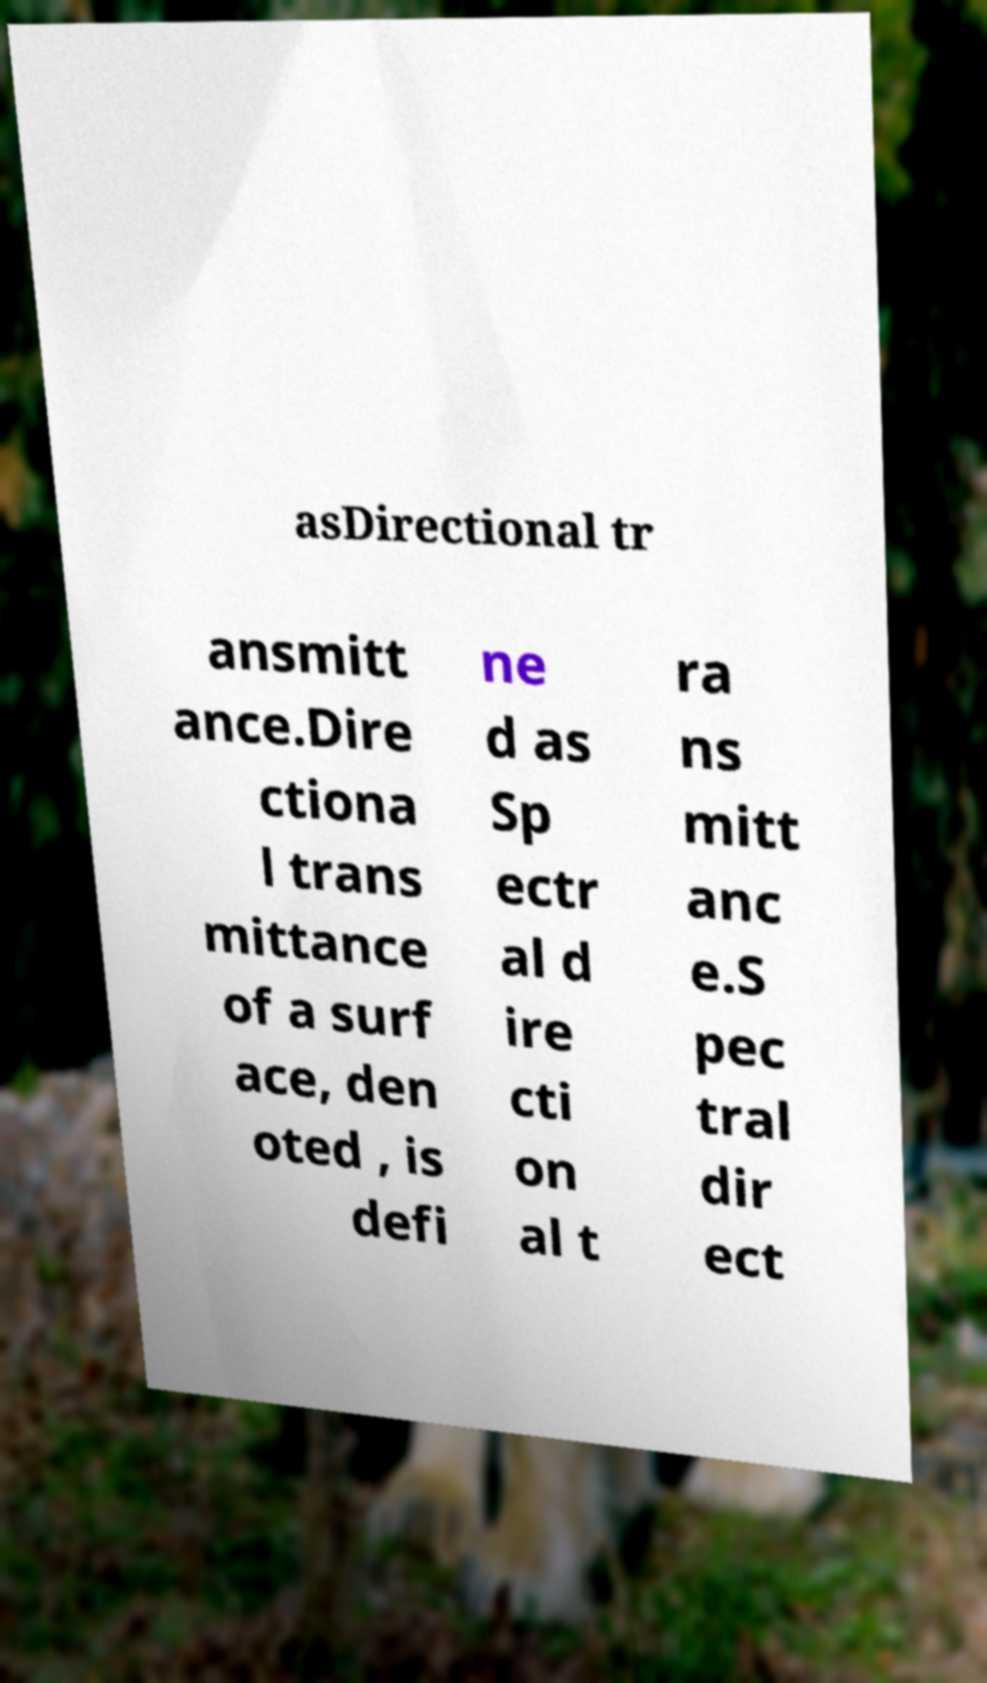Please identify and transcribe the text found in this image. asDirectional tr ansmitt ance.Dire ctiona l trans mittance of a surf ace, den oted , is defi ne d as Sp ectr al d ire cti on al t ra ns mitt anc e.S pec tral dir ect 